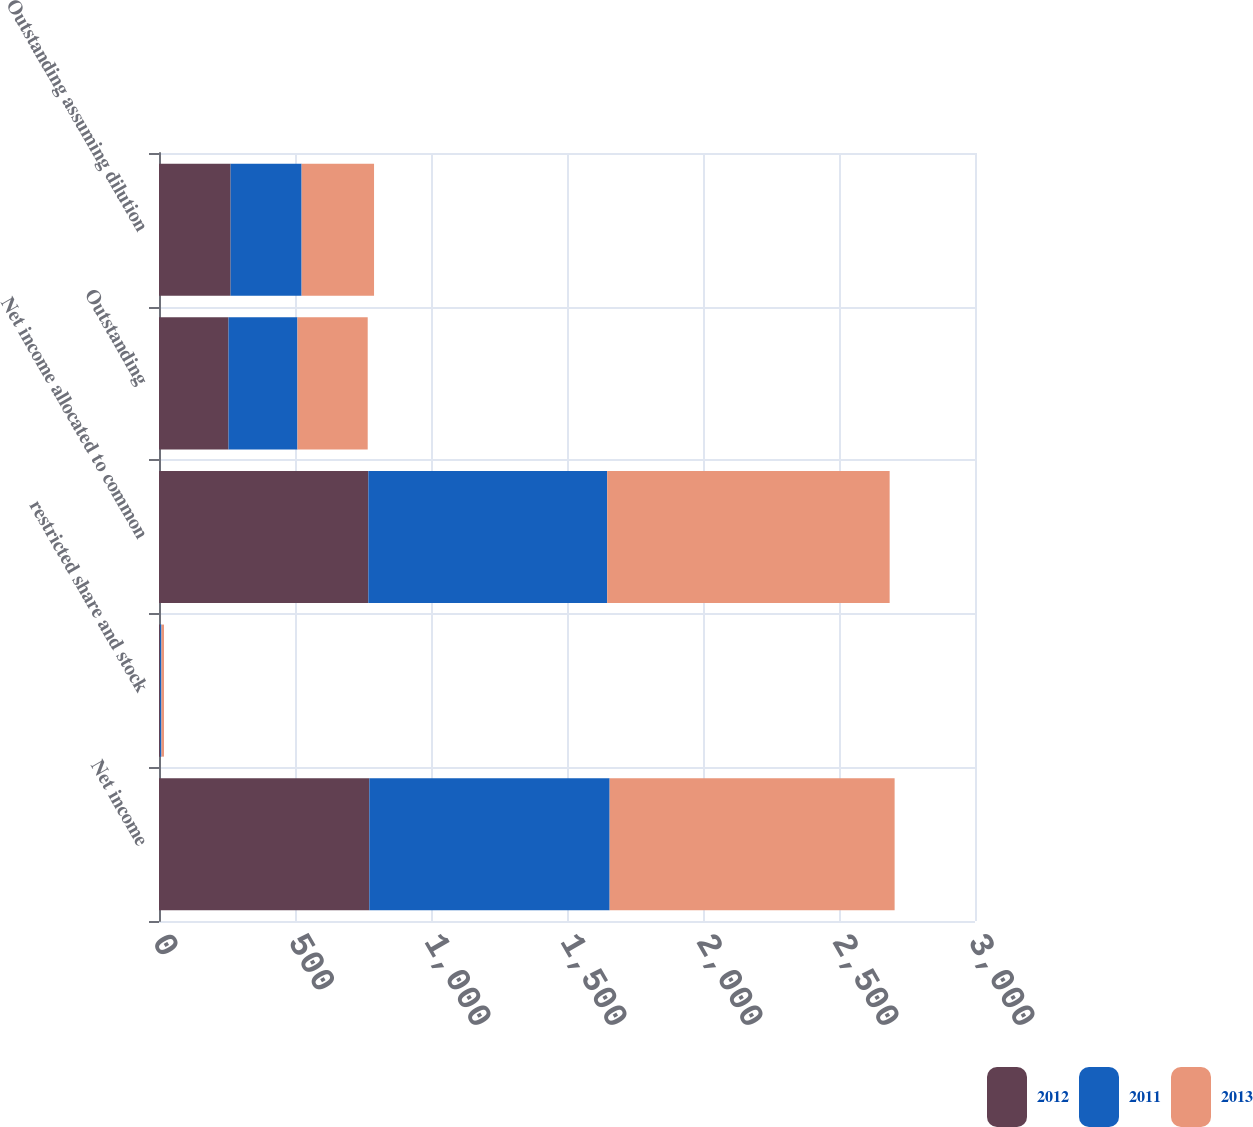Convert chart. <chart><loc_0><loc_0><loc_500><loc_500><stacked_bar_chart><ecel><fcel>Net income<fcel>restricted share and stock<fcel>Net income allocated to common<fcel>Outstanding<fcel>Outstanding assuming dilution<nl><fcel>2012<fcel>773.2<fcel>3.5<fcel>769.7<fcel>255.6<fcel>263.3<nl><fcel>2011<fcel>883.6<fcel>5.5<fcel>878.1<fcel>253.4<fcel>261<nl><fcel>2013<fcel>1047.7<fcel>9.3<fcel>1038.4<fcel>258.3<fcel>266.3<nl></chart> 